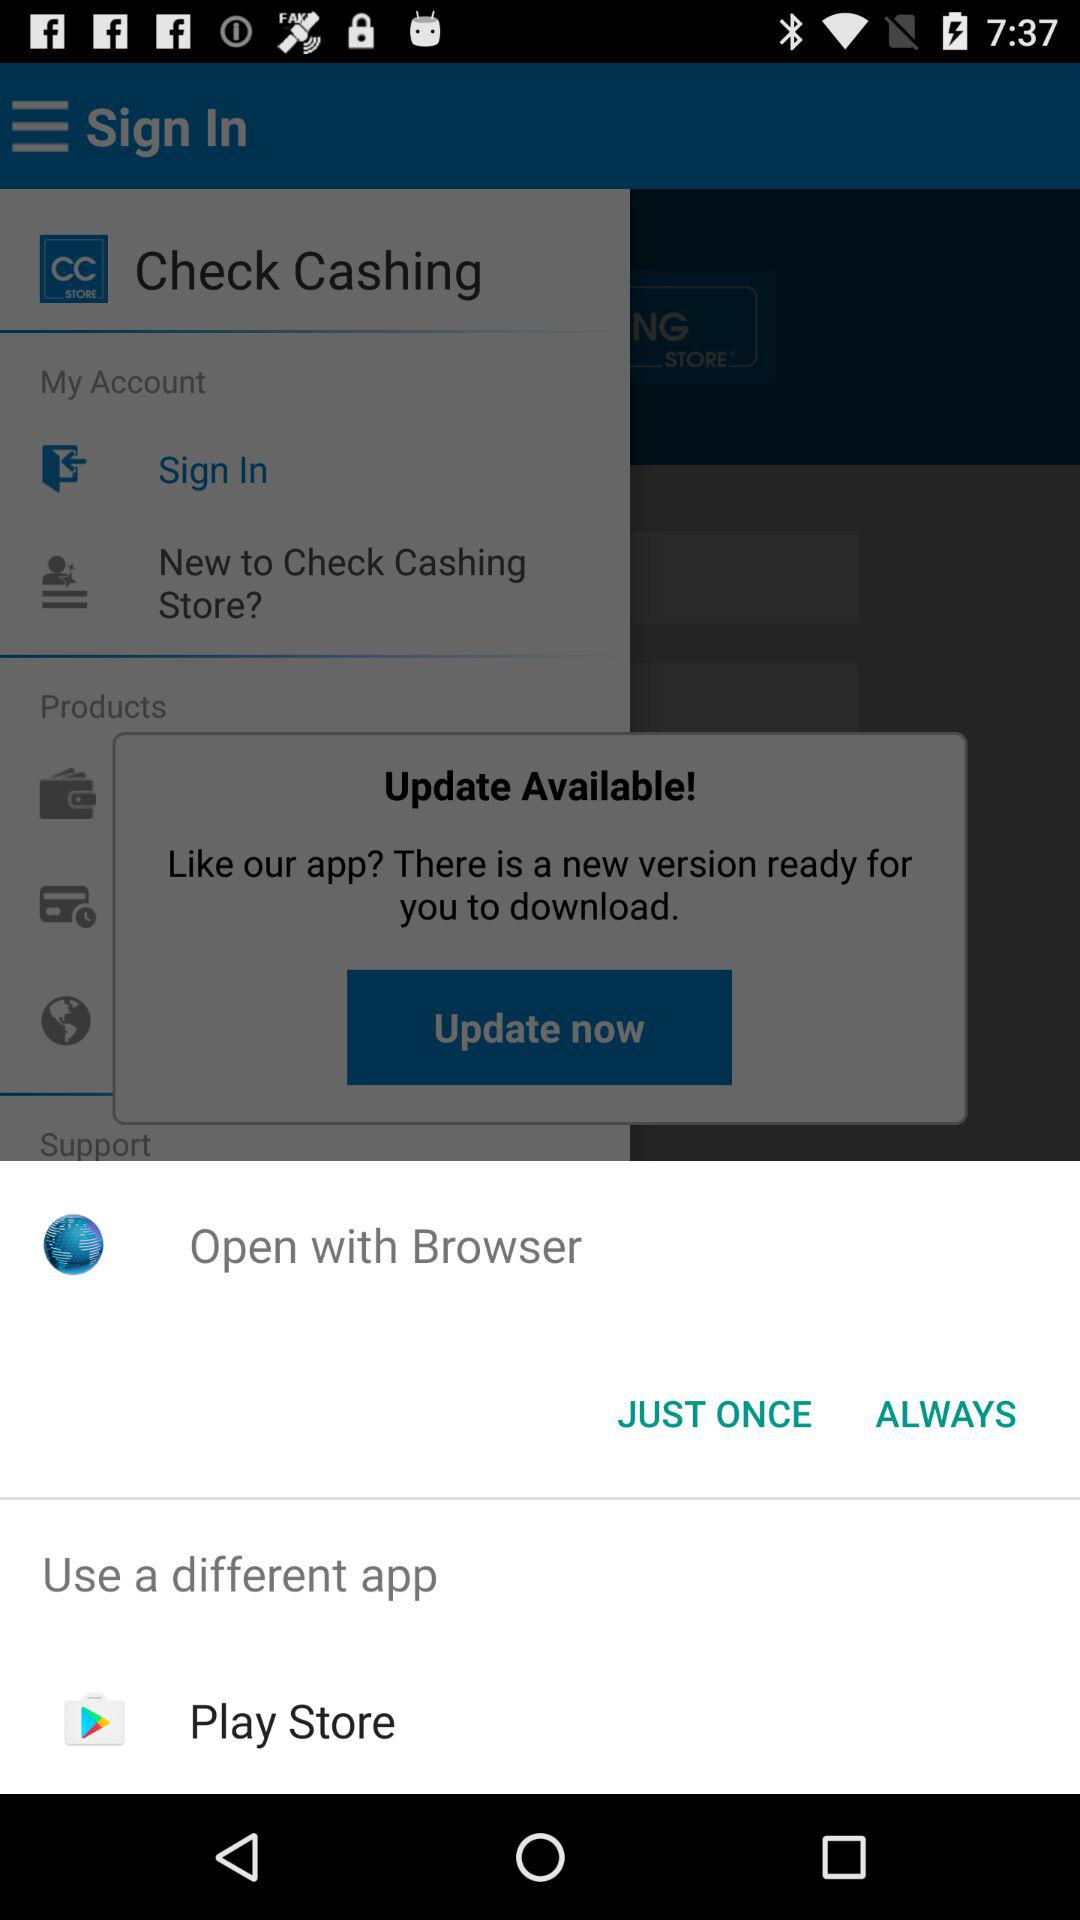What is the name of the application that is being asked to be updated? The name of the application that is being asked to be updated is "Check Cashing". 